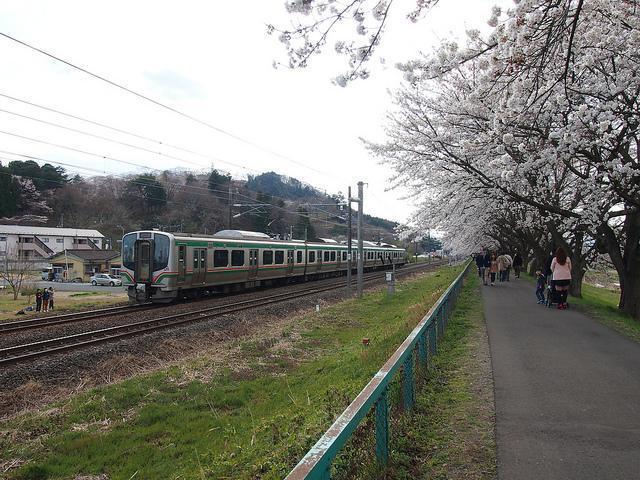How many bowls have eggs?
Give a very brief answer. 0. 